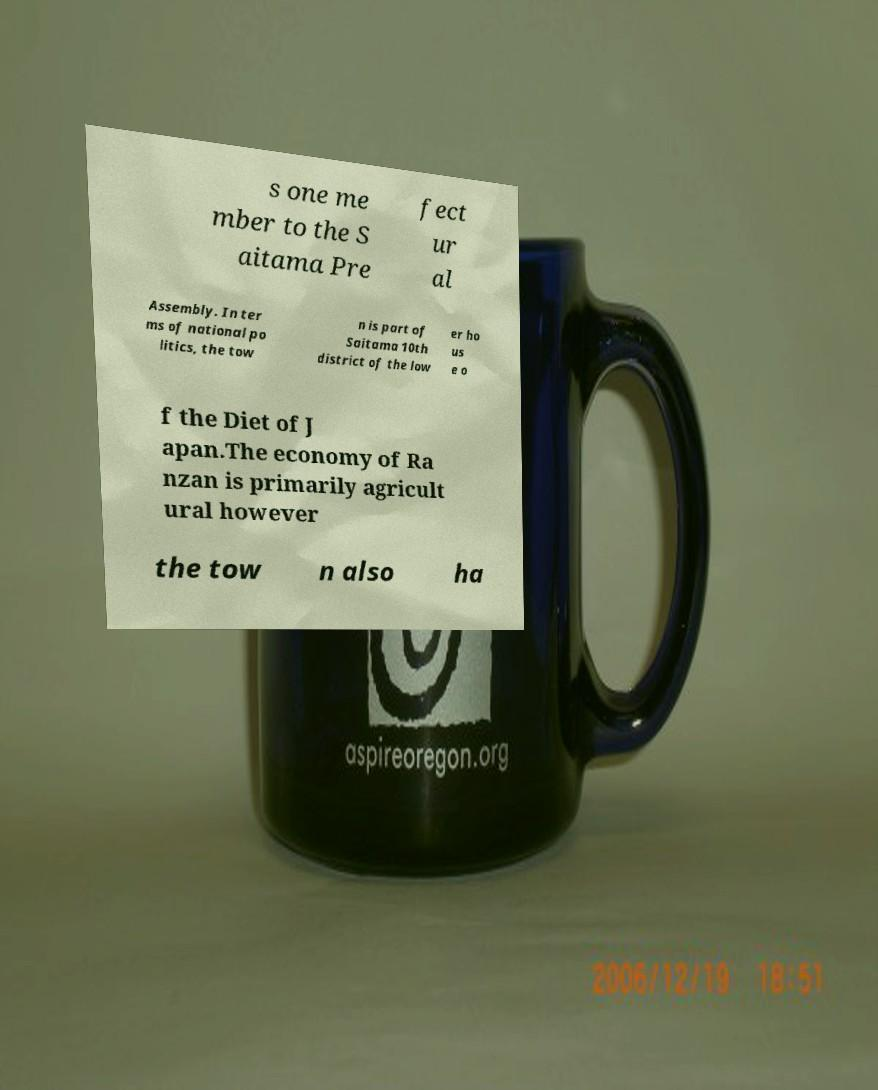I need the written content from this picture converted into text. Can you do that? s one me mber to the S aitama Pre fect ur al Assembly. In ter ms of national po litics, the tow n is part of Saitama 10th district of the low er ho us e o f the Diet of J apan.The economy of Ra nzan is primarily agricult ural however the tow n also ha 